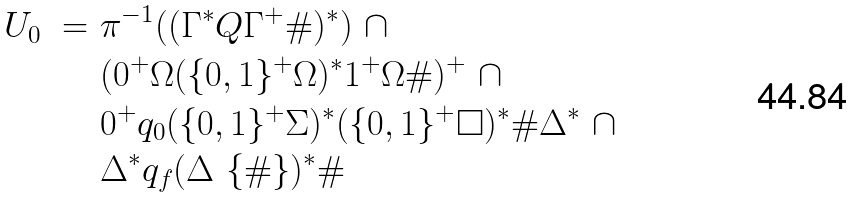<formula> <loc_0><loc_0><loc_500><loc_500>U _ { 0 } \ = \ & \pi ^ { - 1 } ( ( \Gamma ^ { * } Q \Gamma ^ { + } \# ) ^ { * } ) \ \cap \\ & ( 0 ^ { + } \Omega ( \{ 0 , 1 \} ^ { + } \Omega ) ^ { * } 1 ^ { + } \Omega \# ) ^ { + } \ \cap \\ & 0 ^ { + } q _ { 0 } ( \{ 0 , 1 \} ^ { + } \Sigma ) ^ { * } ( \{ 0 , 1 \} ^ { + } \Box ) ^ { * } \# \Delta ^ { * } \ \cap \\ & \Delta ^ { * } q _ { f } ( \Delta \ \{ \# \} ) ^ { * } \#</formula> 